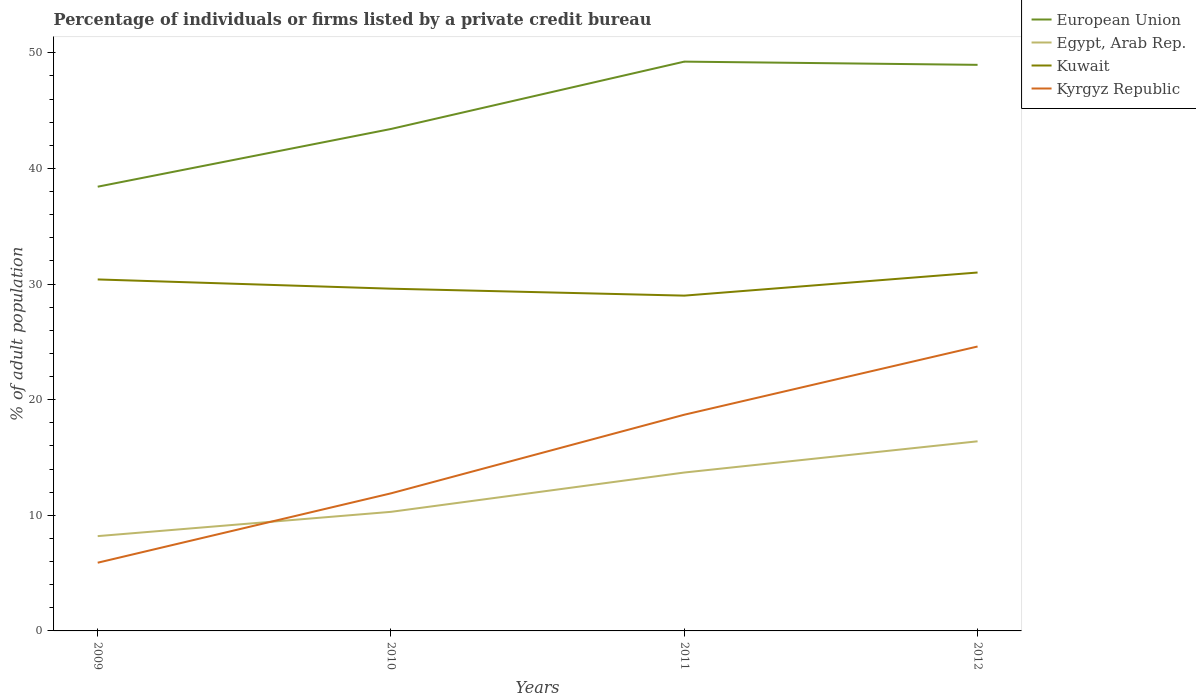Is the number of lines equal to the number of legend labels?
Offer a very short reply. Yes. Across all years, what is the maximum percentage of population listed by a private credit bureau in Kyrgyz Republic?
Offer a very short reply. 5.9. In which year was the percentage of population listed by a private credit bureau in Kuwait maximum?
Ensure brevity in your answer.  2011. What is the total percentage of population listed by a private credit bureau in Kyrgyz Republic in the graph?
Offer a terse response. -12.8. Is the percentage of population listed by a private credit bureau in Egypt, Arab Rep. strictly greater than the percentage of population listed by a private credit bureau in Kuwait over the years?
Your answer should be compact. Yes. How many years are there in the graph?
Your response must be concise. 4. Where does the legend appear in the graph?
Make the answer very short. Top right. How are the legend labels stacked?
Give a very brief answer. Vertical. What is the title of the graph?
Give a very brief answer. Percentage of individuals or firms listed by a private credit bureau. Does "Haiti" appear as one of the legend labels in the graph?
Provide a succinct answer. No. What is the label or title of the Y-axis?
Give a very brief answer. % of adult population. What is the % of adult population in European Union in 2009?
Your answer should be very brief. 38.42. What is the % of adult population of Kuwait in 2009?
Make the answer very short. 30.4. What is the % of adult population in Kyrgyz Republic in 2009?
Keep it short and to the point. 5.9. What is the % of adult population in European Union in 2010?
Keep it short and to the point. 43.41. What is the % of adult population in Kuwait in 2010?
Provide a succinct answer. 29.6. What is the % of adult population in European Union in 2011?
Provide a succinct answer. 49.24. What is the % of adult population in Egypt, Arab Rep. in 2011?
Provide a short and direct response. 13.7. What is the % of adult population in Kuwait in 2011?
Offer a terse response. 29. What is the % of adult population in Kyrgyz Republic in 2011?
Make the answer very short. 18.7. What is the % of adult population of European Union in 2012?
Provide a short and direct response. 48.96. What is the % of adult population of Kuwait in 2012?
Provide a short and direct response. 31. What is the % of adult population of Kyrgyz Republic in 2012?
Offer a very short reply. 24.6. Across all years, what is the maximum % of adult population in European Union?
Your answer should be very brief. 49.24. Across all years, what is the maximum % of adult population in Egypt, Arab Rep.?
Ensure brevity in your answer.  16.4. Across all years, what is the maximum % of adult population of Kyrgyz Republic?
Keep it short and to the point. 24.6. Across all years, what is the minimum % of adult population of European Union?
Provide a succinct answer. 38.42. Across all years, what is the minimum % of adult population of Kuwait?
Make the answer very short. 29. What is the total % of adult population in European Union in the graph?
Ensure brevity in your answer.  180.04. What is the total % of adult population in Egypt, Arab Rep. in the graph?
Make the answer very short. 48.6. What is the total % of adult population in Kuwait in the graph?
Ensure brevity in your answer.  120. What is the total % of adult population in Kyrgyz Republic in the graph?
Offer a very short reply. 61.1. What is the difference between the % of adult population in European Union in 2009 and that in 2010?
Provide a short and direct response. -4.99. What is the difference between the % of adult population in Egypt, Arab Rep. in 2009 and that in 2010?
Keep it short and to the point. -2.1. What is the difference between the % of adult population in European Union in 2009 and that in 2011?
Provide a short and direct response. -10.82. What is the difference between the % of adult population of Egypt, Arab Rep. in 2009 and that in 2011?
Your response must be concise. -5.5. What is the difference between the % of adult population of Kuwait in 2009 and that in 2011?
Keep it short and to the point. 1.4. What is the difference between the % of adult population of Kyrgyz Republic in 2009 and that in 2011?
Ensure brevity in your answer.  -12.8. What is the difference between the % of adult population in European Union in 2009 and that in 2012?
Keep it short and to the point. -10.54. What is the difference between the % of adult population of Kuwait in 2009 and that in 2012?
Provide a succinct answer. -0.6. What is the difference between the % of adult population of Kyrgyz Republic in 2009 and that in 2012?
Keep it short and to the point. -18.7. What is the difference between the % of adult population of European Union in 2010 and that in 2011?
Make the answer very short. -5.82. What is the difference between the % of adult population of European Union in 2010 and that in 2012?
Keep it short and to the point. -5.55. What is the difference between the % of adult population of Kyrgyz Republic in 2010 and that in 2012?
Your answer should be compact. -12.7. What is the difference between the % of adult population in European Union in 2011 and that in 2012?
Give a very brief answer. 0.28. What is the difference between the % of adult population in European Union in 2009 and the % of adult population in Egypt, Arab Rep. in 2010?
Give a very brief answer. 28.12. What is the difference between the % of adult population in European Union in 2009 and the % of adult population in Kuwait in 2010?
Your response must be concise. 8.82. What is the difference between the % of adult population of European Union in 2009 and the % of adult population of Kyrgyz Republic in 2010?
Your answer should be compact. 26.52. What is the difference between the % of adult population in Egypt, Arab Rep. in 2009 and the % of adult population in Kuwait in 2010?
Offer a terse response. -21.4. What is the difference between the % of adult population in European Union in 2009 and the % of adult population in Egypt, Arab Rep. in 2011?
Make the answer very short. 24.72. What is the difference between the % of adult population in European Union in 2009 and the % of adult population in Kuwait in 2011?
Ensure brevity in your answer.  9.42. What is the difference between the % of adult population in European Union in 2009 and the % of adult population in Kyrgyz Republic in 2011?
Offer a terse response. 19.72. What is the difference between the % of adult population of Egypt, Arab Rep. in 2009 and the % of adult population of Kuwait in 2011?
Give a very brief answer. -20.8. What is the difference between the % of adult population in Egypt, Arab Rep. in 2009 and the % of adult population in Kyrgyz Republic in 2011?
Ensure brevity in your answer.  -10.5. What is the difference between the % of adult population in European Union in 2009 and the % of adult population in Egypt, Arab Rep. in 2012?
Your answer should be very brief. 22.02. What is the difference between the % of adult population of European Union in 2009 and the % of adult population of Kuwait in 2012?
Make the answer very short. 7.42. What is the difference between the % of adult population in European Union in 2009 and the % of adult population in Kyrgyz Republic in 2012?
Keep it short and to the point. 13.82. What is the difference between the % of adult population of Egypt, Arab Rep. in 2009 and the % of adult population of Kuwait in 2012?
Make the answer very short. -22.8. What is the difference between the % of adult population in Egypt, Arab Rep. in 2009 and the % of adult population in Kyrgyz Republic in 2012?
Provide a short and direct response. -16.4. What is the difference between the % of adult population of European Union in 2010 and the % of adult population of Egypt, Arab Rep. in 2011?
Your answer should be very brief. 29.71. What is the difference between the % of adult population in European Union in 2010 and the % of adult population in Kuwait in 2011?
Your response must be concise. 14.41. What is the difference between the % of adult population in European Union in 2010 and the % of adult population in Kyrgyz Republic in 2011?
Make the answer very short. 24.71. What is the difference between the % of adult population in Egypt, Arab Rep. in 2010 and the % of adult population in Kuwait in 2011?
Give a very brief answer. -18.7. What is the difference between the % of adult population of Kuwait in 2010 and the % of adult population of Kyrgyz Republic in 2011?
Your answer should be very brief. 10.9. What is the difference between the % of adult population in European Union in 2010 and the % of adult population in Egypt, Arab Rep. in 2012?
Give a very brief answer. 27.01. What is the difference between the % of adult population in European Union in 2010 and the % of adult population in Kuwait in 2012?
Give a very brief answer. 12.41. What is the difference between the % of adult population in European Union in 2010 and the % of adult population in Kyrgyz Republic in 2012?
Ensure brevity in your answer.  18.81. What is the difference between the % of adult population of Egypt, Arab Rep. in 2010 and the % of adult population of Kuwait in 2012?
Your answer should be very brief. -20.7. What is the difference between the % of adult population in Egypt, Arab Rep. in 2010 and the % of adult population in Kyrgyz Republic in 2012?
Give a very brief answer. -14.3. What is the difference between the % of adult population of European Union in 2011 and the % of adult population of Egypt, Arab Rep. in 2012?
Make the answer very short. 32.84. What is the difference between the % of adult population of European Union in 2011 and the % of adult population of Kuwait in 2012?
Provide a short and direct response. 18.24. What is the difference between the % of adult population in European Union in 2011 and the % of adult population in Kyrgyz Republic in 2012?
Your answer should be very brief. 24.64. What is the difference between the % of adult population of Egypt, Arab Rep. in 2011 and the % of adult population of Kuwait in 2012?
Ensure brevity in your answer.  -17.3. What is the difference between the % of adult population of Kuwait in 2011 and the % of adult population of Kyrgyz Republic in 2012?
Offer a terse response. 4.4. What is the average % of adult population in European Union per year?
Your response must be concise. 45.01. What is the average % of adult population in Egypt, Arab Rep. per year?
Your answer should be compact. 12.15. What is the average % of adult population of Kuwait per year?
Make the answer very short. 30. What is the average % of adult population of Kyrgyz Republic per year?
Offer a terse response. 15.28. In the year 2009, what is the difference between the % of adult population in European Union and % of adult population in Egypt, Arab Rep.?
Give a very brief answer. 30.22. In the year 2009, what is the difference between the % of adult population of European Union and % of adult population of Kuwait?
Give a very brief answer. 8.02. In the year 2009, what is the difference between the % of adult population in European Union and % of adult population in Kyrgyz Republic?
Your answer should be very brief. 32.52. In the year 2009, what is the difference between the % of adult population in Egypt, Arab Rep. and % of adult population in Kuwait?
Make the answer very short. -22.2. In the year 2009, what is the difference between the % of adult population in Kuwait and % of adult population in Kyrgyz Republic?
Keep it short and to the point. 24.5. In the year 2010, what is the difference between the % of adult population of European Union and % of adult population of Egypt, Arab Rep.?
Offer a terse response. 33.11. In the year 2010, what is the difference between the % of adult population in European Union and % of adult population in Kuwait?
Ensure brevity in your answer.  13.81. In the year 2010, what is the difference between the % of adult population in European Union and % of adult population in Kyrgyz Republic?
Ensure brevity in your answer.  31.51. In the year 2010, what is the difference between the % of adult population in Egypt, Arab Rep. and % of adult population in Kuwait?
Your answer should be compact. -19.3. In the year 2011, what is the difference between the % of adult population of European Union and % of adult population of Egypt, Arab Rep.?
Keep it short and to the point. 35.54. In the year 2011, what is the difference between the % of adult population of European Union and % of adult population of Kuwait?
Provide a succinct answer. 20.24. In the year 2011, what is the difference between the % of adult population in European Union and % of adult population in Kyrgyz Republic?
Give a very brief answer. 30.54. In the year 2011, what is the difference between the % of adult population in Egypt, Arab Rep. and % of adult population in Kuwait?
Offer a terse response. -15.3. In the year 2011, what is the difference between the % of adult population of Egypt, Arab Rep. and % of adult population of Kyrgyz Republic?
Provide a succinct answer. -5. In the year 2011, what is the difference between the % of adult population in Kuwait and % of adult population in Kyrgyz Republic?
Offer a very short reply. 10.3. In the year 2012, what is the difference between the % of adult population of European Union and % of adult population of Egypt, Arab Rep.?
Your answer should be compact. 32.56. In the year 2012, what is the difference between the % of adult population of European Union and % of adult population of Kuwait?
Give a very brief answer. 17.96. In the year 2012, what is the difference between the % of adult population of European Union and % of adult population of Kyrgyz Republic?
Ensure brevity in your answer.  24.36. In the year 2012, what is the difference between the % of adult population in Egypt, Arab Rep. and % of adult population in Kuwait?
Provide a succinct answer. -14.6. In the year 2012, what is the difference between the % of adult population of Egypt, Arab Rep. and % of adult population of Kyrgyz Republic?
Offer a very short reply. -8.2. In the year 2012, what is the difference between the % of adult population of Kuwait and % of adult population of Kyrgyz Republic?
Offer a very short reply. 6.4. What is the ratio of the % of adult population of European Union in 2009 to that in 2010?
Offer a terse response. 0.89. What is the ratio of the % of adult population of Egypt, Arab Rep. in 2009 to that in 2010?
Keep it short and to the point. 0.8. What is the ratio of the % of adult population in Kuwait in 2009 to that in 2010?
Provide a short and direct response. 1.03. What is the ratio of the % of adult population of Kyrgyz Republic in 2009 to that in 2010?
Make the answer very short. 0.5. What is the ratio of the % of adult population of European Union in 2009 to that in 2011?
Your answer should be very brief. 0.78. What is the ratio of the % of adult population in Egypt, Arab Rep. in 2009 to that in 2011?
Your answer should be very brief. 0.6. What is the ratio of the % of adult population of Kuwait in 2009 to that in 2011?
Your answer should be compact. 1.05. What is the ratio of the % of adult population in Kyrgyz Republic in 2009 to that in 2011?
Your answer should be compact. 0.32. What is the ratio of the % of adult population of European Union in 2009 to that in 2012?
Your answer should be compact. 0.78. What is the ratio of the % of adult population in Kuwait in 2009 to that in 2012?
Ensure brevity in your answer.  0.98. What is the ratio of the % of adult population of Kyrgyz Republic in 2009 to that in 2012?
Provide a succinct answer. 0.24. What is the ratio of the % of adult population in European Union in 2010 to that in 2011?
Provide a succinct answer. 0.88. What is the ratio of the % of adult population of Egypt, Arab Rep. in 2010 to that in 2011?
Give a very brief answer. 0.75. What is the ratio of the % of adult population of Kuwait in 2010 to that in 2011?
Give a very brief answer. 1.02. What is the ratio of the % of adult population in Kyrgyz Republic in 2010 to that in 2011?
Your answer should be very brief. 0.64. What is the ratio of the % of adult population of European Union in 2010 to that in 2012?
Your answer should be compact. 0.89. What is the ratio of the % of adult population in Egypt, Arab Rep. in 2010 to that in 2012?
Provide a short and direct response. 0.63. What is the ratio of the % of adult population of Kuwait in 2010 to that in 2012?
Ensure brevity in your answer.  0.95. What is the ratio of the % of adult population in Kyrgyz Republic in 2010 to that in 2012?
Your response must be concise. 0.48. What is the ratio of the % of adult population in Egypt, Arab Rep. in 2011 to that in 2012?
Your response must be concise. 0.84. What is the ratio of the % of adult population in Kuwait in 2011 to that in 2012?
Offer a terse response. 0.94. What is the ratio of the % of adult population of Kyrgyz Republic in 2011 to that in 2012?
Provide a short and direct response. 0.76. What is the difference between the highest and the second highest % of adult population of European Union?
Offer a terse response. 0.28. What is the difference between the highest and the second highest % of adult population in Kyrgyz Republic?
Give a very brief answer. 5.9. What is the difference between the highest and the lowest % of adult population of European Union?
Ensure brevity in your answer.  10.82. What is the difference between the highest and the lowest % of adult population of Kyrgyz Republic?
Your response must be concise. 18.7. 